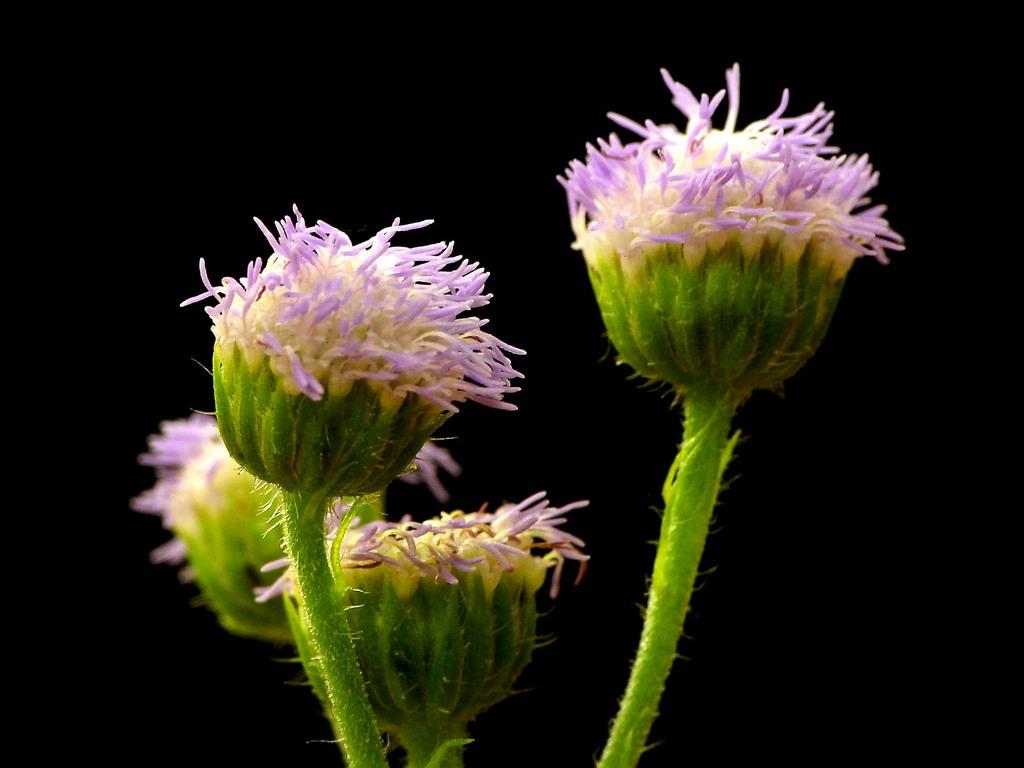What colors can be seen in the flowers in the image? The flowers in the image have white and violet colors. What part of the flowers connects them to the ground or a vase? The flowers have stems. How would you describe the overall appearance of the image? The background of the image is dark. What type of iron is being used to press the flowers in the image? There is no iron present in the image; it features flowers with stems and a dark background. How does the powder help the flowers in the image? There is no powder mentioned or visible in the image; it only shows flowers with stems and a dark background. 